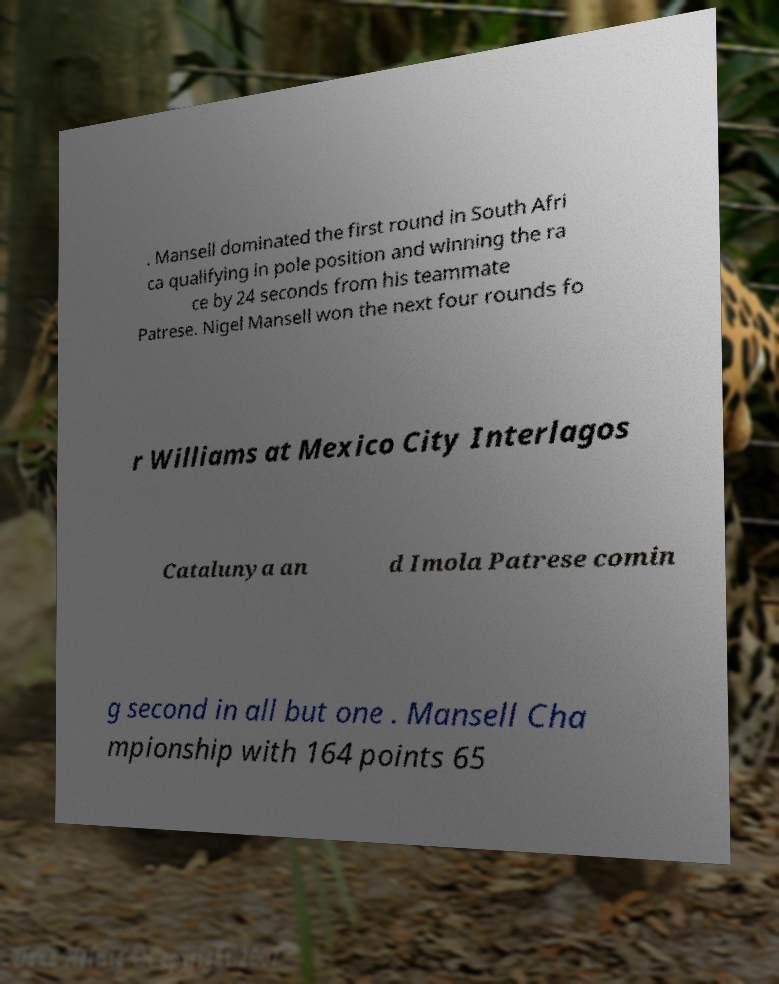Please identify and transcribe the text found in this image. . Mansell dominated the first round in South Afri ca qualifying in pole position and winning the ra ce by 24 seconds from his teammate Patrese. Nigel Mansell won the next four rounds fo r Williams at Mexico City Interlagos Catalunya an d Imola Patrese comin g second in all but one . Mansell Cha mpionship with 164 points 65 